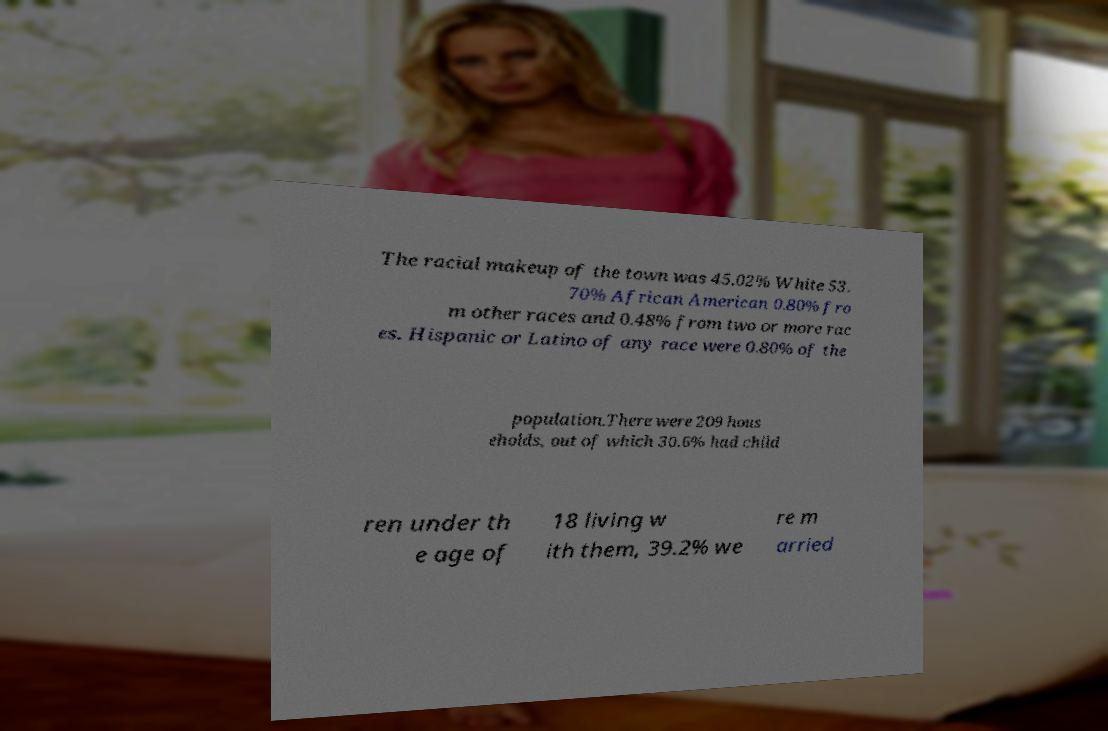There's text embedded in this image that I need extracted. Can you transcribe it verbatim? The racial makeup of the town was 45.02% White 53. 70% African American 0.80% fro m other races and 0.48% from two or more rac es. Hispanic or Latino of any race were 0.80% of the population.There were 209 hous eholds, out of which 30.6% had child ren under th e age of 18 living w ith them, 39.2% we re m arried 